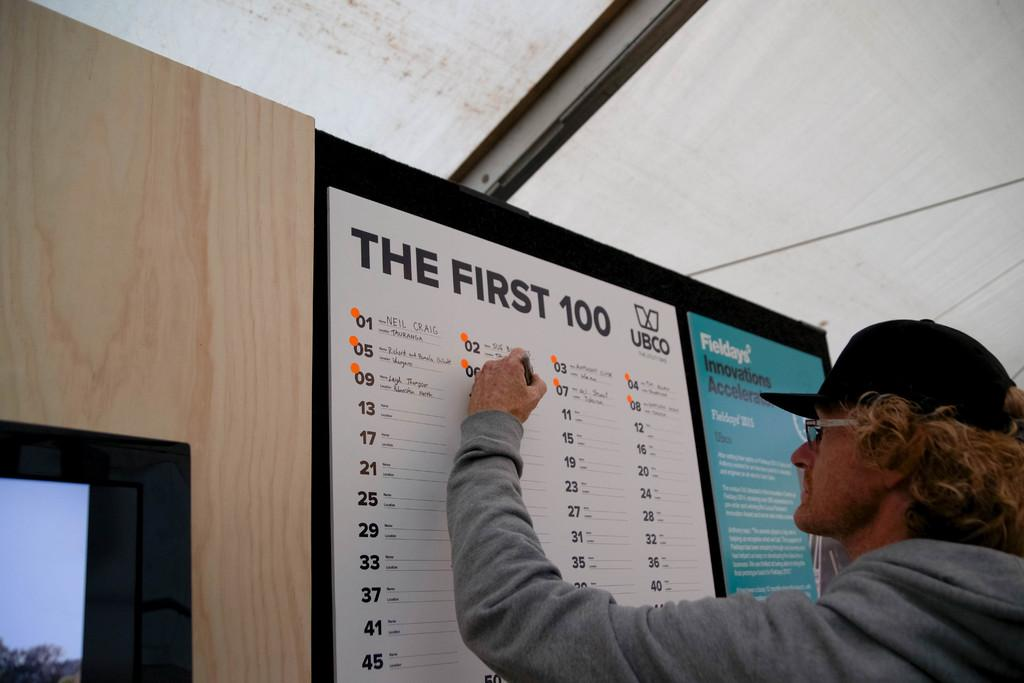<image>
Render a clear and concise summary of the photo. A man putting his information on The First 100 sign-up sheet for UBCO. 